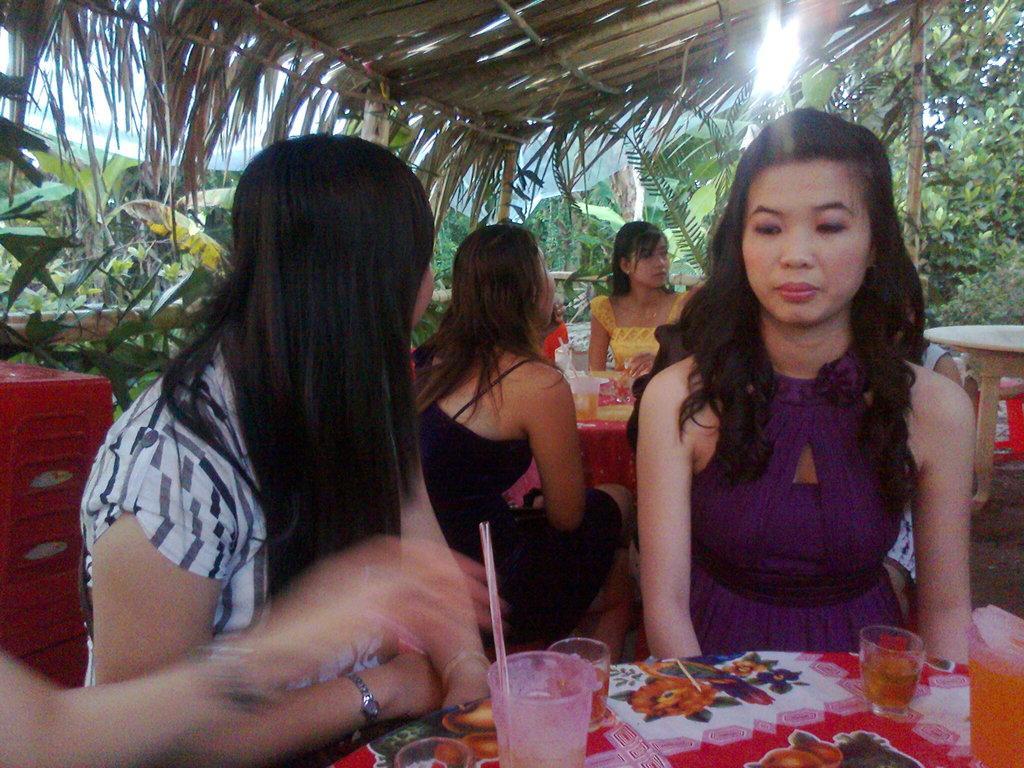In one or two sentences, can you explain what this image depicts? In front of the image there are two women sitting on chairs, in front of them on the table there are some objects, behind them there are a few other woman sitting. Around them there are tables and chairs, on the tables there are some objects. Behind them there are trees. At the top of the image there is a dry grass rooftop supported with wooden poles. 